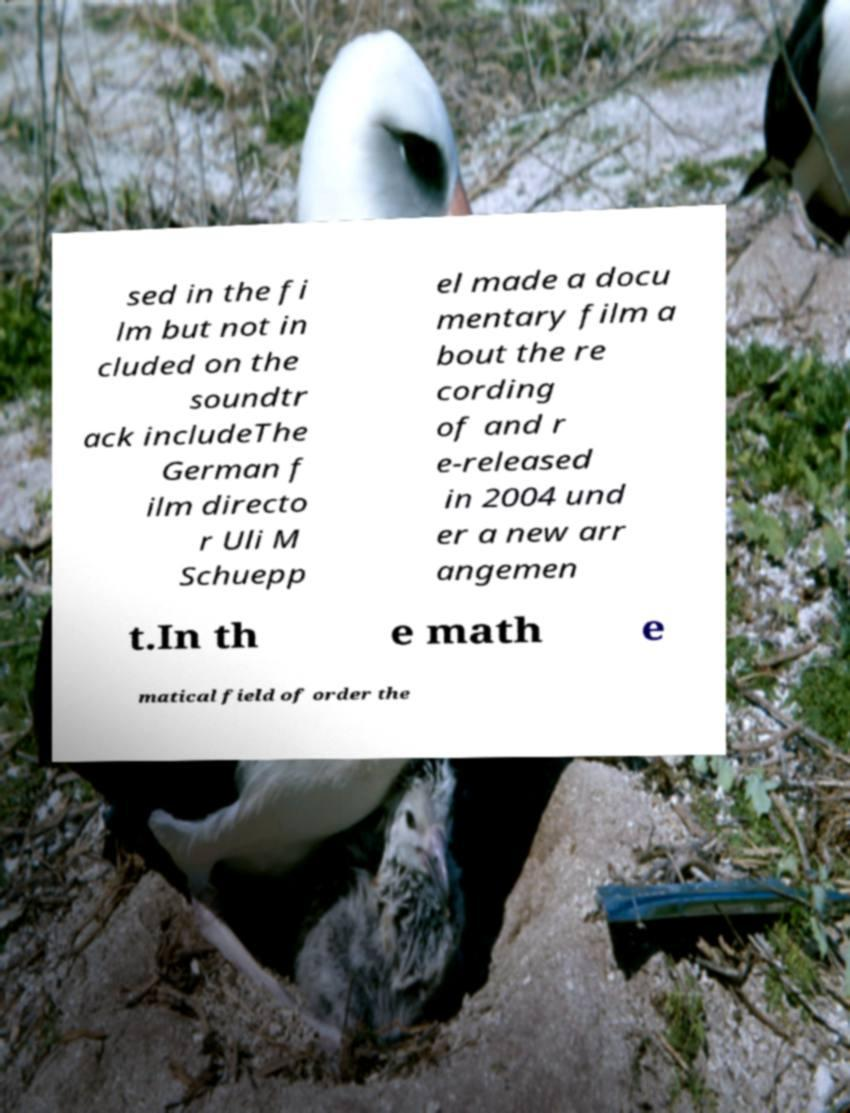There's text embedded in this image that I need extracted. Can you transcribe it verbatim? sed in the fi lm but not in cluded on the soundtr ack includeThe German f ilm directo r Uli M Schuepp el made a docu mentary film a bout the re cording of and r e-released in 2004 und er a new arr angemen t.In th e math e matical field of order the 